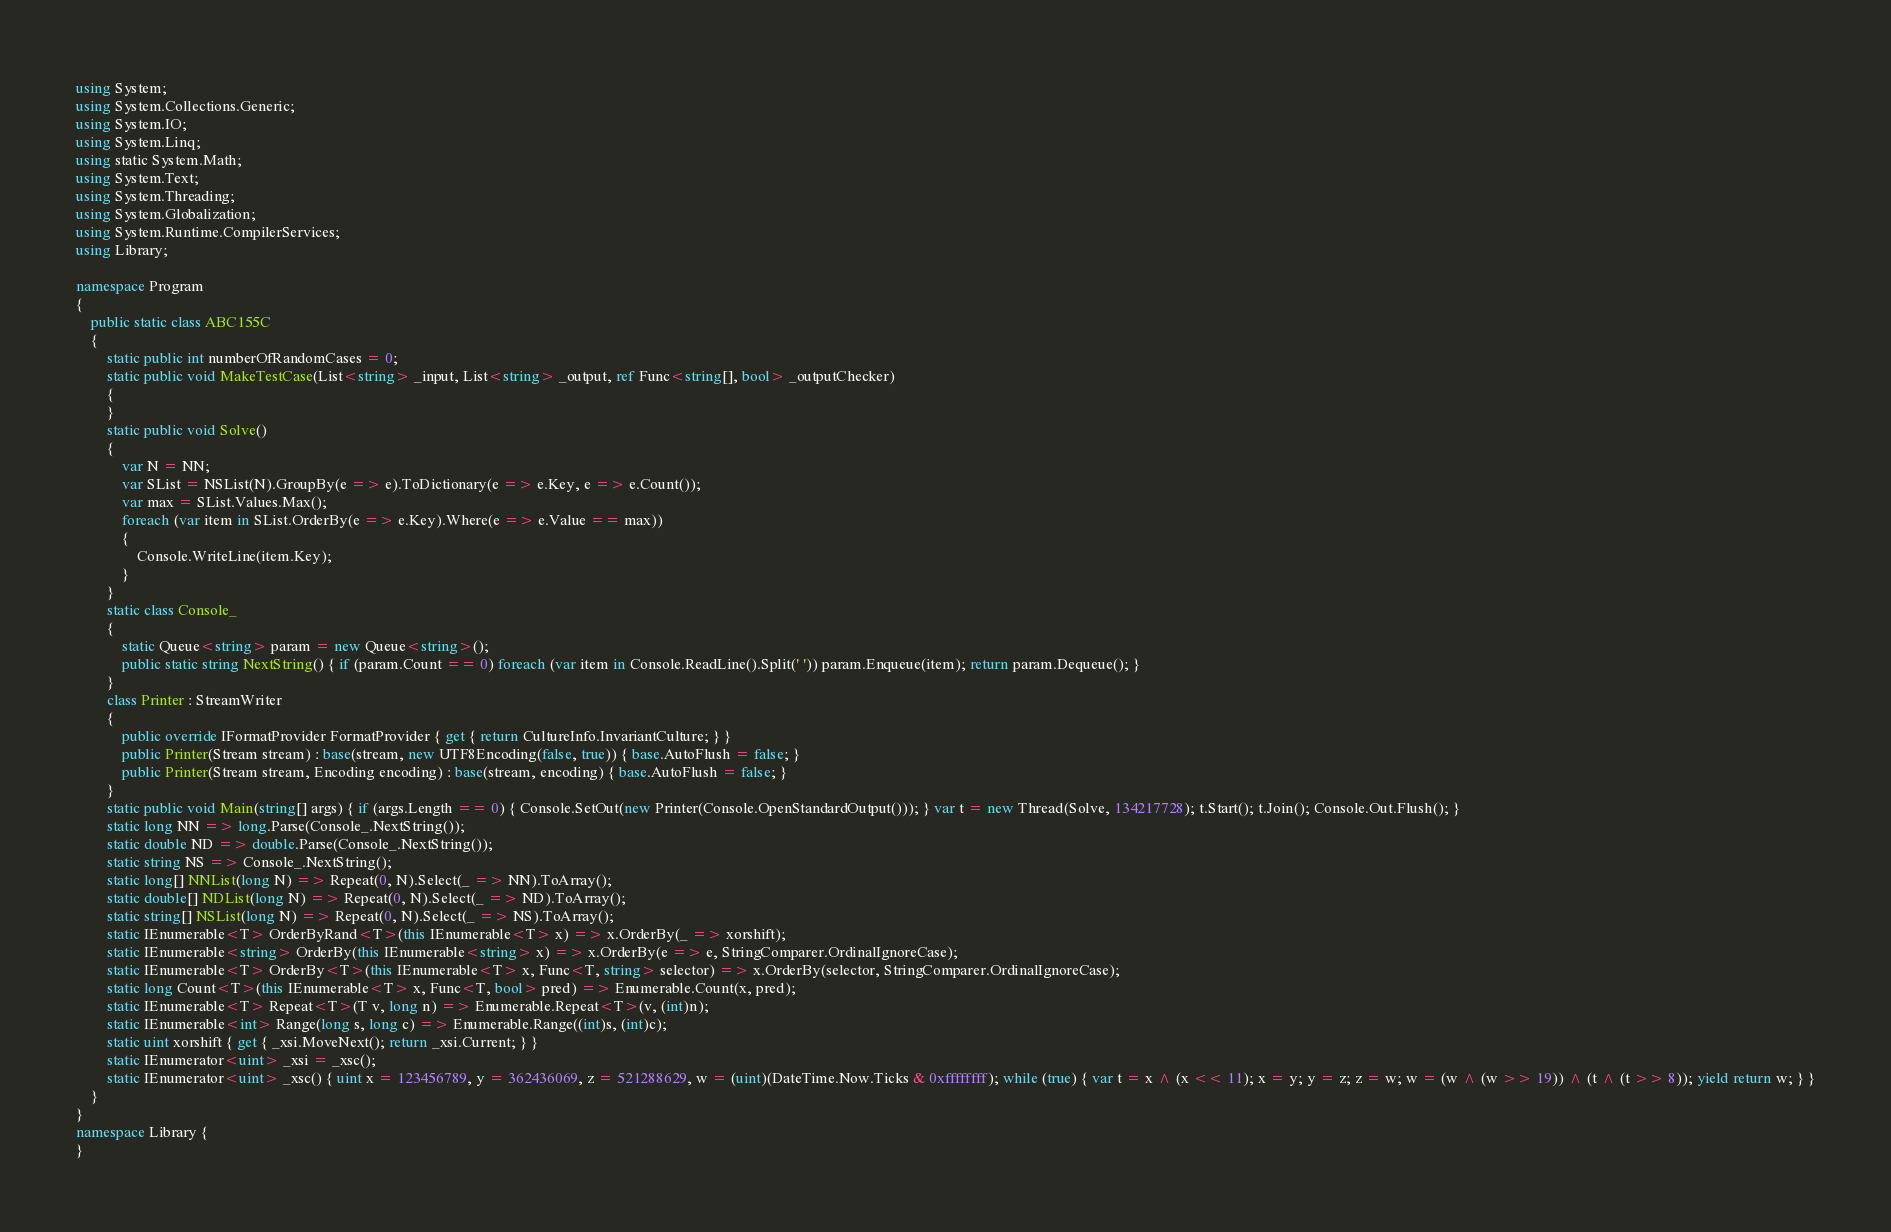<code> <loc_0><loc_0><loc_500><loc_500><_C#_>using System;
using System.Collections.Generic;
using System.IO;
using System.Linq;
using static System.Math;
using System.Text;
using System.Threading;
using System.Globalization;
using System.Runtime.CompilerServices;
using Library;

namespace Program
{
    public static class ABC155C
    {
        static public int numberOfRandomCases = 0;
        static public void MakeTestCase(List<string> _input, List<string> _output, ref Func<string[], bool> _outputChecker)
        {
        }
        static public void Solve()
        {
            var N = NN;
            var SList = NSList(N).GroupBy(e => e).ToDictionary(e => e.Key, e => e.Count());
            var max = SList.Values.Max();
            foreach (var item in SList.OrderBy(e => e.Key).Where(e => e.Value == max))
            {
                Console.WriteLine(item.Key);
            }
        }
        static class Console_
        {
            static Queue<string> param = new Queue<string>();
            public static string NextString() { if (param.Count == 0) foreach (var item in Console.ReadLine().Split(' ')) param.Enqueue(item); return param.Dequeue(); }
        }
        class Printer : StreamWriter
        {
            public override IFormatProvider FormatProvider { get { return CultureInfo.InvariantCulture; } }
            public Printer(Stream stream) : base(stream, new UTF8Encoding(false, true)) { base.AutoFlush = false; }
            public Printer(Stream stream, Encoding encoding) : base(stream, encoding) { base.AutoFlush = false; }
        }
        static public void Main(string[] args) { if (args.Length == 0) { Console.SetOut(new Printer(Console.OpenStandardOutput())); } var t = new Thread(Solve, 134217728); t.Start(); t.Join(); Console.Out.Flush(); }
        static long NN => long.Parse(Console_.NextString());
        static double ND => double.Parse(Console_.NextString());
        static string NS => Console_.NextString();
        static long[] NNList(long N) => Repeat(0, N).Select(_ => NN).ToArray();
        static double[] NDList(long N) => Repeat(0, N).Select(_ => ND).ToArray();
        static string[] NSList(long N) => Repeat(0, N).Select(_ => NS).ToArray();
        static IEnumerable<T> OrderByRand<T>(this IEnumerable<T> x) => x.OrderBy(_ => xorshift);
        static IEnumerable<string> OrderBy(this IEnumerable<string> x) => x.OrderBy(e => e, StringComparer.OrdinalIgnoreCase);
        static IEnumerable<T> OrderBy<T>(this IEnumerable<T> x, Func<T, string> selector) => x.OrderBy(selector, StringComparer.OrdinalIgnoreCase);
        static long Count<T>(this IEnumerable<T> x, Func<T, bool> pred) => Enumerable.Count(x, pred);
        static IEnumerable<T> Repeat<T>(T v, long n) => Enumerable.Repeat<T>(v, (int)n);
        static IEnumerable<int> Range(long s, long c) => Enumerable.Range((int)s, (int)c);
        static uint xorshift { get { _xsi.MoveNext(); return _xsi.Current; } }
        static IEnumerator<uint> _xsi = _xsc();
        static IEnumerator<uint> _xsc() { uint x = 123456789, y = 362436069, z = 521288629, w = (uint)(DateTime.Now.Ticks & 0xffffffff); while (true) { var t = x ^ (x << 11); x = y; y = z; z = w; w = (w ^ (w >> 19)) ^ (t ^ (t >> 8)); yield return w; } }
    }
}
namespace Library {
}
</code> 